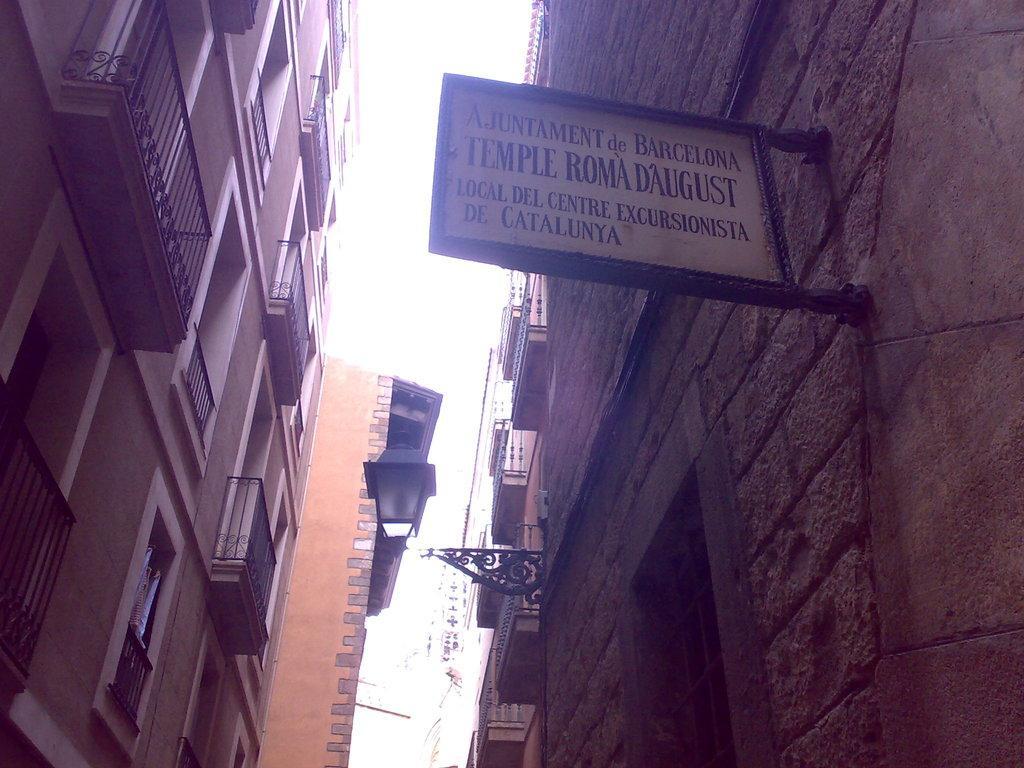Could you give a brief overview of what you see in this image? In the picture we can see a building on the either sides and to the building we can see railings and windows and on the opposite building we can see a board with some information on it and in the middle of the building we can see a sky. 